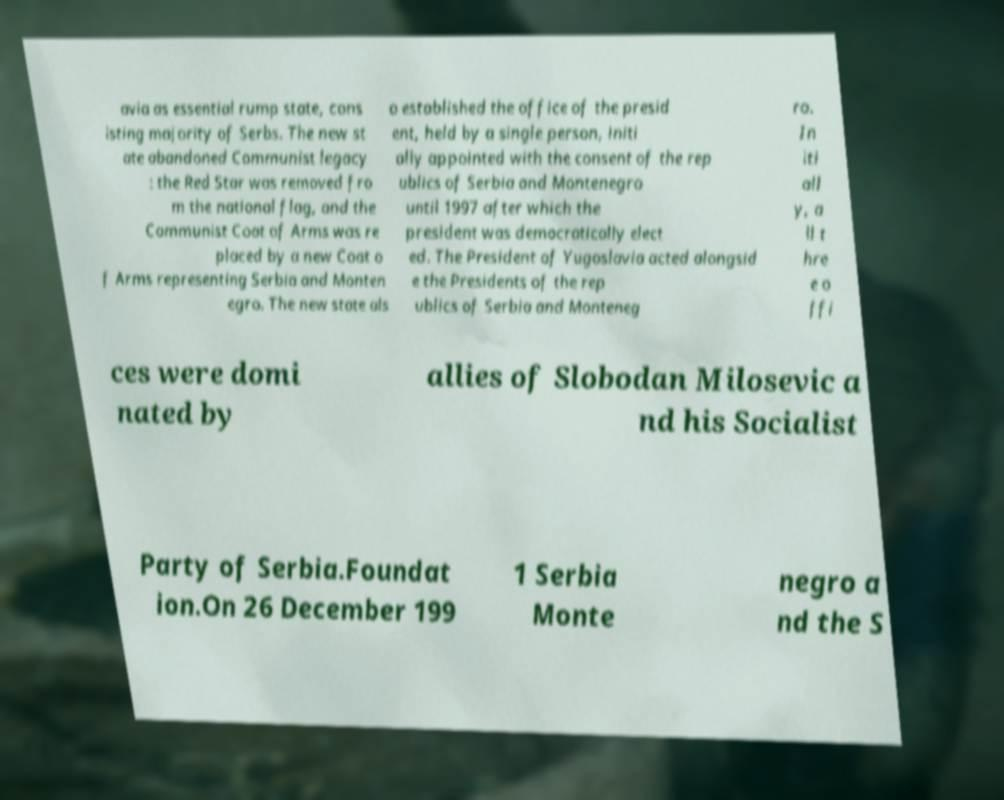What messages or text are displayed in this image? I need them in a readable, typed format. avia as essential rump state, cons isting majority of Serbs. The new st ate abandoned Communist legacy : the Red Star was removed fro m the national flag, and the Communist Coat of Arms was re placed by a new Coat o f Arms representing Serbia and Monten egro. The new state als o established the office of the presid ent, held by a single person, initi ally appointed with the consent of the rep ublics of Serbia and Montenegro until 1997 after which the president was democratically elect ed. The President of Yugoslavia acted alongsid e the Presidents of the rep ublics of Serbia and Monteneg ro. In iti all y, a ll t hre e o ffi ces were domi nated by allies of Slobodan Milosevic a nd his Socialist Party of Serbia.Foundat ion.On 26 December 199 1 Serbia Monte negro a nd the S 